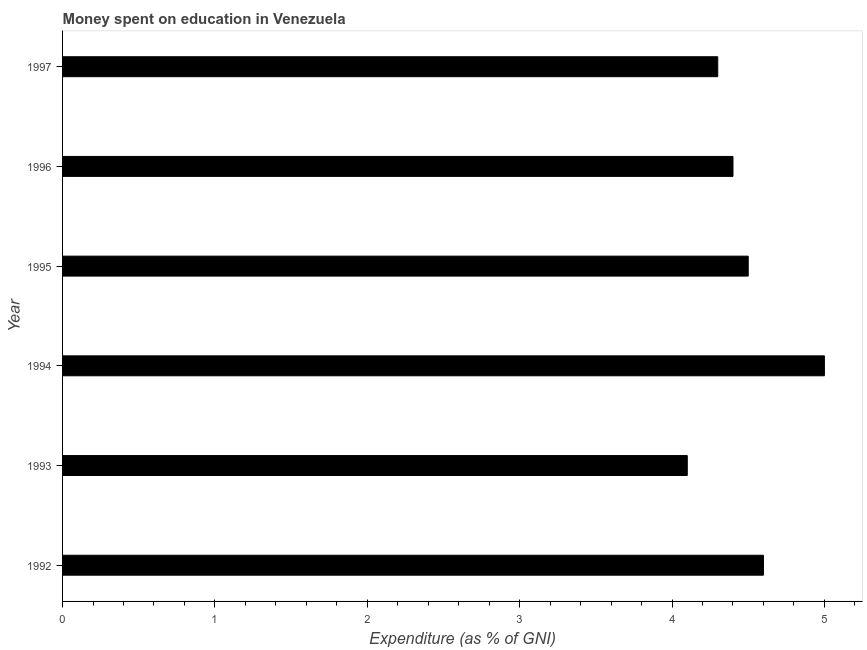Does the graph contain any zero values?
Give a very brief answer. No. Does the graph contain grids?
Offer a very short reply. No. What is the title of the graph?
Offer a very short reply. Money spent on education in Venezuela. What is the label or title of the X-axis?
Provide a short and direct response. Expenditure (as % of GNI). What is the expenditure on education in 1996?
Your answer should be compact. 4.4. Across all years, what is the maximum expenditure on education?
Provide a short and direct response. 5. In which year was the expenditure on education minimum?
Ensure brevity in your answer.  1993. What is the sum of the expenditure on education?
Keep it short and to the point. 26.9. What is the difference between the expenditure on education in 1994 and 1997?
Your answer should be compact. 0.7. What is the average expenditure on education per year?
Keep it short and to the point. 4.48. What is the median expenditure on education?
Keep it short and to the point. 4.45. In how many years, is the expenditure on education greater than 2.6 %?
Offer a very short reply. 6. What is the ratio of the expenditure on education in 1993 to that in 1995?
Your answer should be compact. 0.91. Is the expenditure on education in 1995 less than that in 1996?
Your answer should be very brief. No. Is the difference between the expenditure on education in 1993 and 1994 greater than the difference between any two years?
Ensure brevity in your answer.  Yes. In how many years, is the expenditure on education greater than the average expenditure on education taken over all years?
Ensure brevity in your answer.  3. How many years are there in the graph?
Your response must be concise. 6. What is the Expenditure (as % of GNI) in 1992?
Provide a succinct answer. 4.6. What is the Expenditure (as % of GNI) of 1997?
Give a very brief answer. 4.3. What is the difference between the Expenditure (as % of GNI) in 1992 and 1993?
Provide a short and direct response. 0.5. What is the difference between the Expenditure (as % of GNI) in 1992 and 1994?
Give a very brief answer. -0.4. What is the difference between the Expenditure (as % of GNI) in 1992 and 1995?
Your answer should be compact. 0.1. What is the difference between the Expenditure (as % of GNI) in 1992 and 1997?
Keep it short and to the point. 0.3. What is the difference between the Expenditure (as % of GNI) in 1993 and 1994?
Ensure brevity in your answer.  -0.9. What is the difference between the Expenditure (as % of GNI) in 1993 and 1995?
Give a very brief answer. -0.4. What is the difference between the Expenditure (as % of GNI) in 1993 and 1996?
Provide a short and direct response. -0.3. What is the difference between the Expenditure (as % of GNI) in 1994 and 1995?
Keep it short and to the point. 0.5. What is the difference between the Expenditure (as % of GNI) in 1994 and 1996?
Ensure brevity in your answer.  0.6. What is the difference between the Expenditure (as % of GNI) in 1995 and 1996?
Give a very brief answer. 0.1. What is the difference between the Expenditure (as % of GNI) in 1995 and 1997?
Keep it short and to the point. 0.2. What is the ratio of the Expenditure (as % of GNI) in 1992 to that in 1993?
Your answer should be compact. 1.12. What is the ratio of the Expenditure (as % of GNI) in 1992 to that in 1995?
Provide a short and direct response. 1.02. What is the ratio of the Expenditure (as % of GNI) in 1992 to that in 1996?
Your response must be concise. 1.04. What is the ratio of the Expenditure (as % of GNI) in 1992 to that in 1997?
Make the answer very short. 1.07. What is the ratio of the Expenditure (as % of GNI) in 1993 to that in 1994?
Provide a short and direct response. 0.82. What is the ratio of the Expenditure (as % of GNI) in 1993 to that in 1995?
Keep it short and to the point. 0.91. What is the ratio of the Expenditure (as % of GNI) in 1993 to that in 1996?
Give a very brief answer. 0.93. What is the ratio of the Expenditure (as % of GNI) in 1993 to that in 1997?
Give a very brief answer. 0.95. What is the ratio of the Expenditure (as % of GNI) in 1994 to that in 1995?
Your answer should be very brief. 1.11. What is the ratio of the Expenditure (as % of GNI) in 1994 to that in 1996?
Give a very brief answer. 1.14. What is the ratio of the Expenditure (as % of GNI) in 1994 to that in 1997?
Give a very brief answer. 1.16. What is the ratio of the Expenditure (as % of GNI) in 1995 to that in 1996?
Make the answer very short. 1.02. What is the ratio of the Expenditure (as % of GNI) in 1995 to that in 1997?
Your response must be concise. 1.05. What is the ratio of the Expenditure (as % of GNI) in 1996 to that in 1997?
Make the answer very short. 1.02. 